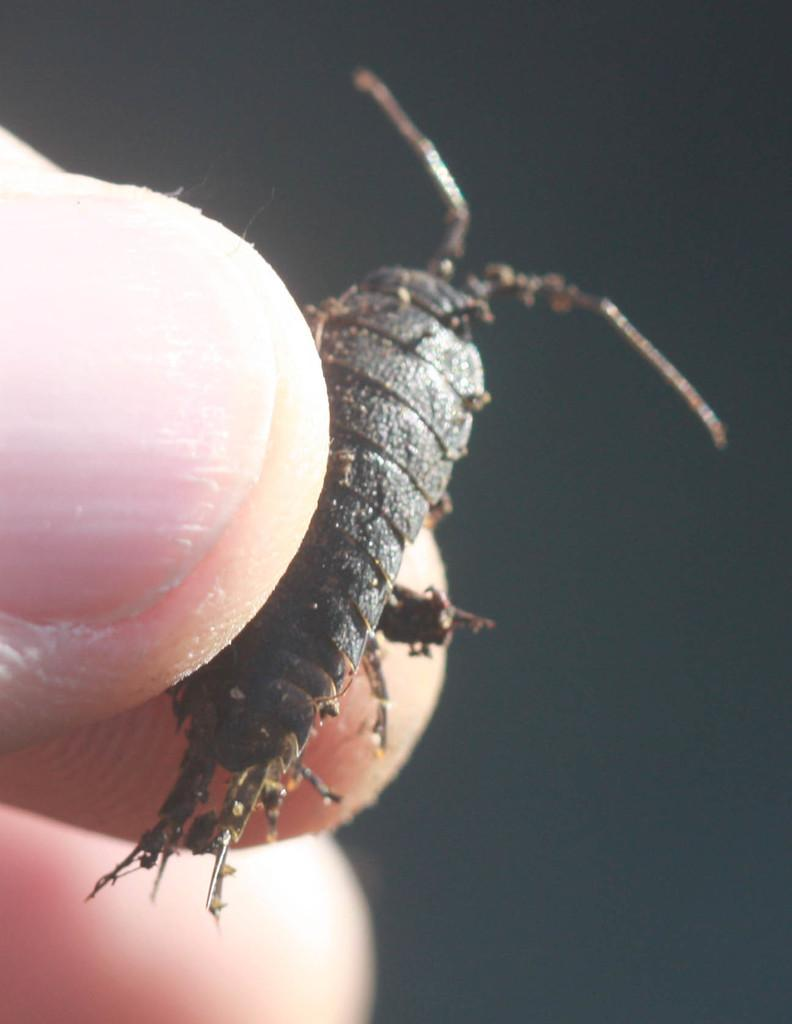What is the main subject of the image? The main subject of the image is a person's fingers holding an insect. Can you describe the background of the image? The background of the image is dark. What type of action is the person performing with the tub in the image? There is no tub present in the image, and therefore no action involving a tub can be observed. 